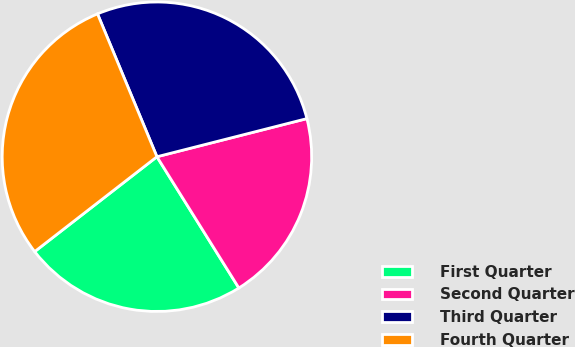Convert chart. <chart><loc_0><loc_0><loc_500><loc_500><pie_chart><fcel>First Quarter<fcel>Second Quarter<fcel>Third Quarter<fcel>Fourth Quarter<nl><fcel>23.38%<fcel>20.08%<fcel>27.31%<fcel>29.23%<nl></chart> 